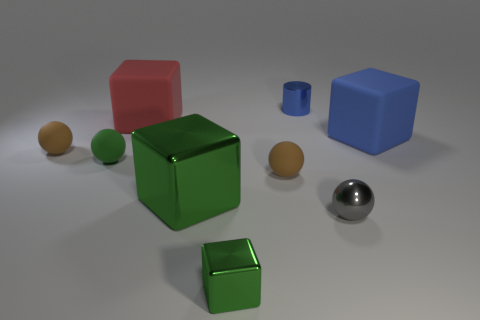Subtract all cyan balls. Subtract all purple cylinders. How many balls are left? 4 Add 1 large brown metal things. How many objects exist? 10 Subtract all cubes. How many objects are left? 5 Subtract 1 red blocks. How many objects are left? 8 Subtract all matte spheres. Subtract all red matte things. How many objects are left? 5 Add 7 blue cubes. How many blue cubes are left? 8 Add 5 big gray rubber things. How many big gray rubber things exist? 5 